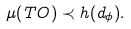Convert formula to latex. <formula><loc_0><loc_0><loc_500><loc_500>\mu ( T O ) \prec h ( d _ { \phi } ) .</formula> 